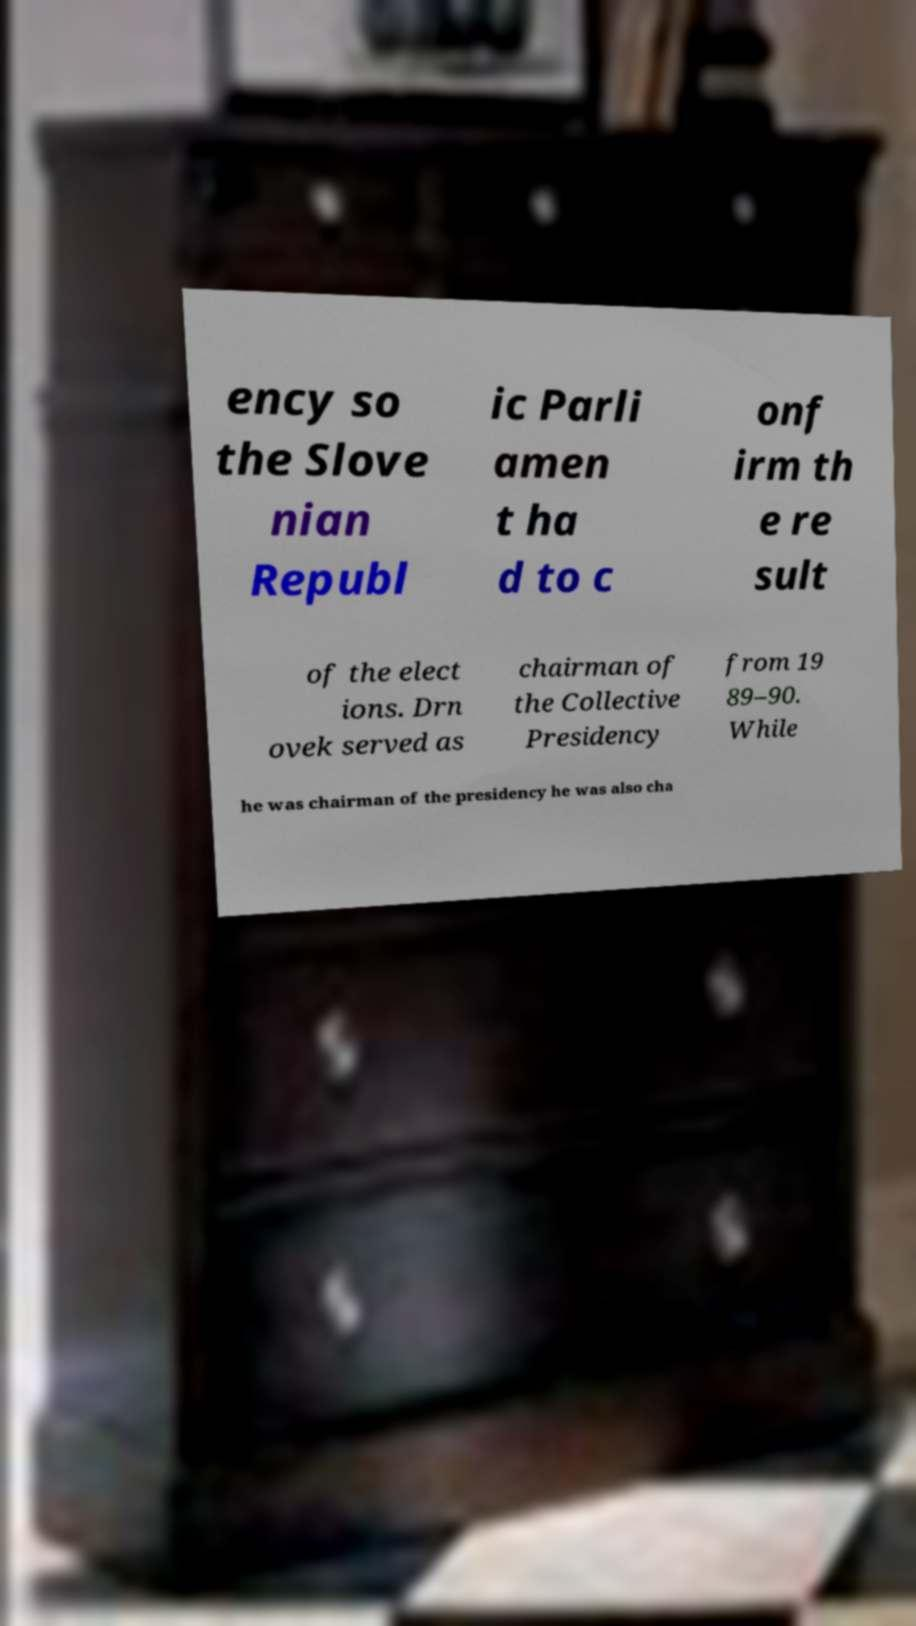Could you extract and type out the text from this image? ency so the Slove nian Republ ic Parli amen t ha d to c onf irm th e re sult of the elect ions. Drn ovek served as chairman of the Collective Presidency from 19 89–90. While he was chairman of the presidency he was also cha 